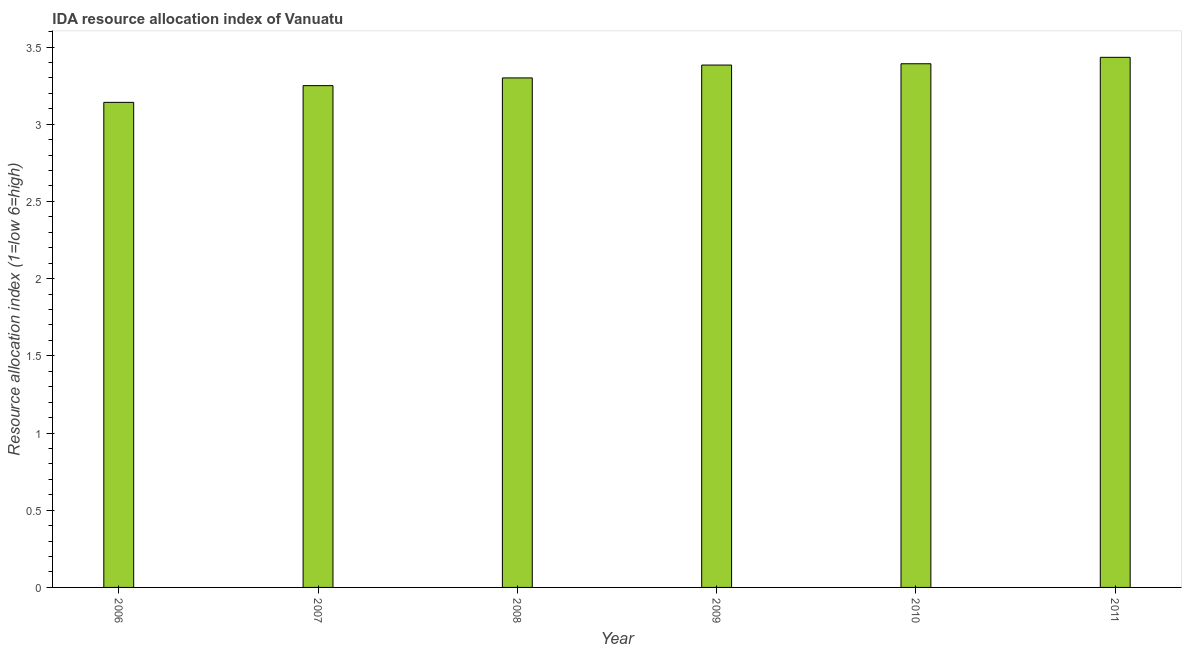What is the title of the graph?
Provide a succinct answer. IDA resource allocation index of Vanuatu. What is the label or title of the X-axis?
Ensure brevity in your answer.  Year. What is the label or title of the Y-axis?
Provide a short and direct response. Resource allocation index (1=low 6=high). What is the ida resource allocation index in 2010?
Offer a very short reply. 3.39. Across all years, what is the maximum ida resource allocation index?
Make the answer very short. 3.43. Across all years, what is the minimum ida resource allocation index?
Give a very brief answer. 3.14. In which year was the ida resource allocation index maximum?
Your answer should be very brief. 2011. What is the sum of the ida resource allocation index?
Your response must be concise. 19.9. What is the difference between the ida resource allocation index in 2006 and 2009?
Ensure brevity in your answer.  -0.24. What is the average ida resource allocation index per year?
Your answer should be compact. 3.32. What is the median ida resource allocation index?
Your answer should be compact. 3.34. Is the difference between the ida resource allocation index in 2006 and 2010 greater than the difference between any two years?
Provide a short and direct response. No. What is the difference between the highest and the second highest ida resource allocation index?
Offer a very short reply. 0.04. Is the sum of the ida resource allocation index in 2008 and 2009 greater than the maximum ida resource allocation index across all years?
Ensure brevity in your answer.  Yes. What is the difference between the highest and the lowest ida resource allocation index?
Your answer should be very brief. 0.29. What is the Resource allocation index (1=low 6=high) in 2006?
Keep it short and to the point. 3.14. What is the Resource allocation index (1=low 6=high) in 2007?
Offer a terse response. 3.25. What is the Resource allocation index (1=low 6=high) of 2008?
Your answer should be compact. 3.3. What is the Resource allocation index (1=low 6=high) in 2009?
Keep it short and to the point. 3.38. What is the Resource allocation index (1=low 6=high) of 2010?
Make the answer very short. 3.39. What is the Resource allocation index (1=low 6=high) in 2011?
Give a very brief answer. 3.43. What is the difference between the Resource allocation index (1=low 6=high) in 2006 and 2007?
Your response must be concise. -0.11. What is the difference between the Resource allocation index (1=low 6=high) in 2006 and 2008?
Keep it short and to the point. -0.16. What is the difference between the Resource allocation index (1=low 6=high) in 2006 and 2009?
Give a very brief answer. -0.24. What is the difference between the Resource allocation index (1=low 6=high) in 2006 and 2010?
Make the answer very short. -0.25. What is the difference between the Resource allocation index (1=low 6=high) in 2006 and 2011?
Your answer should be very brief. -0.29. What is the difference between the Resource allocation index (1=low 6=high) in 2007 and 2008?
Keep it short and to the point. -0.05. What is the difference between the Resource allocation index (1=low 6=high) in 2007 and 2009?
Make the answer very short. -0.13. What is the difference between the Resource allocation index (1=low 6=high) in 2007 and 2010?
Provide a succinct answer. -0.14. What is the difference between the Resource allocation index (1=low 6=high) in 2007 and 2011?
Offer a very short reply. -0.18. What is the difference between the Resource allocation index (1=low 6=high) in 2008 and 2009?
Your answer should be compact. -0.08. What is the difference between the Resource allocation index (1=low 6=high) in 2008 and 2010?
Ensure brevity in your answer.  -0.09. What is the difference between the Resource allocation index (1=low 6=high) in 2008 and 2011?
Keep it short and to the point. -0.13. What is the difference between the Resource allocation index (1=low 6=high) in 2009 and 2010?
Ensure brevity in your answer.  -0.01. What is the difference between the Resource allocation index (1=low 6=high) in 2010 and 2011?
Your answer should be compact. -0.04. What is the ratio of the Resource allocation index (1=low 6=high) in 2006 to that in 2007?
Offer a very short reply. 0.97. What is the ratio of the Resource allocation index (1=low 6=high) in 2006 to that in 2008?
Your response must be concise. 0.95. What is the ratio of the Resource allocation index (1=low 6=high) in 2006 to that in 2009?
Offer a very short reply. 0.93. What is the ratio of the Resource allocation index (1=low 6=high) in 2006 to that in 2010?
Your response must be concise. 0.93. What is the ratio of the Resource allocation index (1=low 6=high) in 2006 to that in 2011?
Your answer should be very brief. 0.92. What is the ratio of the Resource allocation index (1=low 6=high) in 2007 to that in 2009?
Make the answer very short. 0.96. What is the ratio of the Resource allocation index (1=low 6=high) in 2007 to that in 2010?
Provide a succinct answer. 0.96. What is the ratio of the Resource allocation index (1=low 6=high) in 2007 to that in 2011?
Ensure brevity in your answer.  0.95. What is the ratio of the Resource allocation index (1=low 6=high) in 2008 to that in 2010?
Ensure brevity in your answer.  0.97. What is the ratio of the Resource allocation index (1=low 6=high) in 2009 to that in 2010?
Give a very brief answer. 1. What is the ratio of the Resource allocation index (1=low 6=high) in 2009 to that in 2011?
Provide a short and direct response. 0.98. 